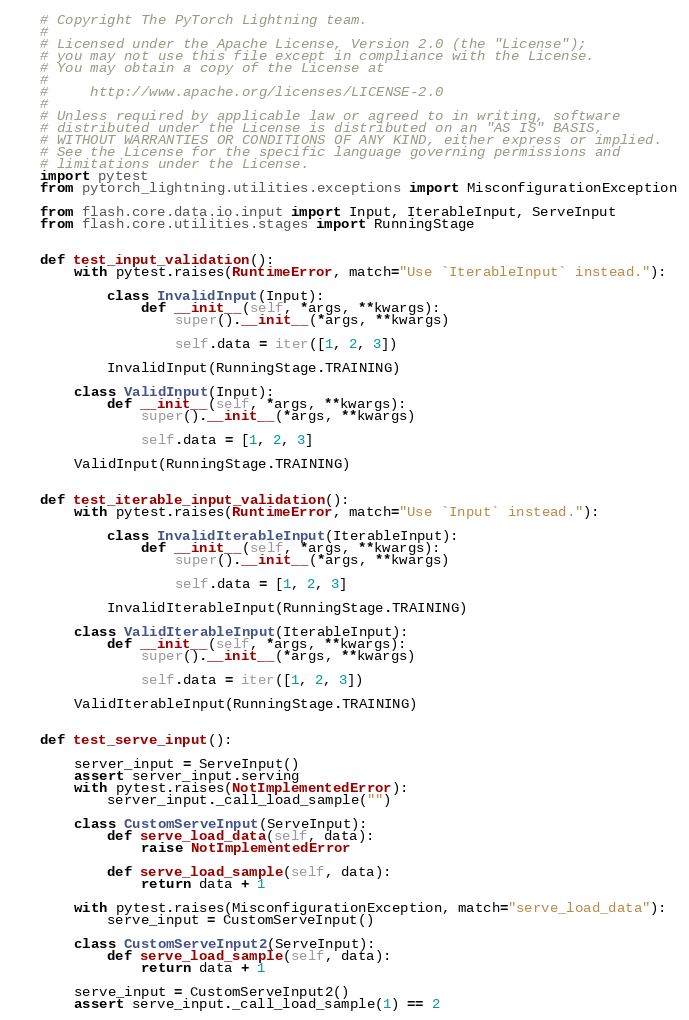<code> <loc_0><loc_0><loc_500><loc_500><_Python_># Copyright The PyTorch Lightning team.
#
# Licensed under the Apache License, Version 2.0 (the "License");
# you may not use this file except in compliance with the License.
# You may obtain a copy of the License at
#
#     http://www.apache.org/licenses/LICENSE-2.0
#
# Unless required by applicable law or agreed to in writing, software
# distributed under the License is distributed on an "AS IS" BASIS,
# WITHOUT WARRANTIES OR CONDITIONS OF ANY KIND, either express or implied.
# See the License for the specific language governing permissions and
# limitations under the License.
import pytest
from pytorch_lightning.utilities.exceptions import MisconfigurationException

from flash.core.data.io.input import Input, IterableInput, ServeInput
from flash.core.utilities.stages import RunningStage


def test_input_validation():
    with pytest.raises(RuntimeError, match="Use `IterableInput` instead."):

        class InvalidInput(Input):
            def __init__(self, *args, **kwargs):
                super().__init__(*args, **kwargs)

                self.data = iter([1, 2, 3])

        InvalidInput(RunningStage.TRAINING)

    class ValidInput(Input):
        def __init__(self, *args, **kwargs):
            super().__init__(*args, **kwargs)

            self.data = [1, 2, 3]

    ValidInput(RunningStage.TRAINING)


def test_iterable_input_validation():
    with pytest.raises(RuntimeError, match="Use `Input` instead."):

        class InvalidIterableInput(IterableInput):
            def __init__(self, *args, **kwargs):
                super().__init__(*args, **kwargs)

                self.data = [1, 2, 3]

        InvalidIterableInput(RunningStage.TRAINING)

    class ValidIterableInput(IterableInput):
        def __init__(self, *args, **kwargs):
            super().__init__(*args, **kwargs)

            self.data = iter([1, 2, 3])

    ValidIterableInput(RunningStage.TRAINING)


def test_serve_input():

    server_input = ServeInput()
    assert server_input.serving
    with pytest.raises(NotImplementedError):
        server_input._call_load_sample("")

    class CustomServeInput(ServeInput):
        def serve_load_data(self, data):
            raise NotImplementedError

        def serve_load_sample(self, data):
            return data + 1

    with pytest.raises(MisconfigurationException, match="serve_load_data"):
        serve_input = CustomServeInput()

    class CustomServeInput2(ServeInput):
        def serve_load_sample(self, data):
            return data + 1

    serve_input = CustomServeInput2()
    assert serve_input._call_load_sample(1) == 2
</code> 